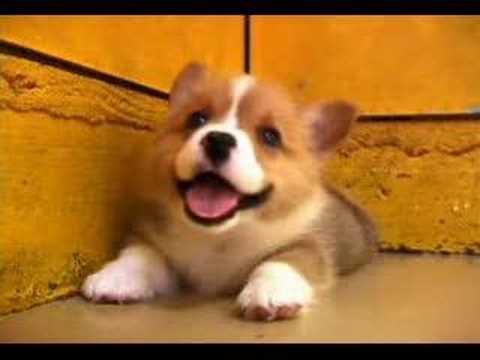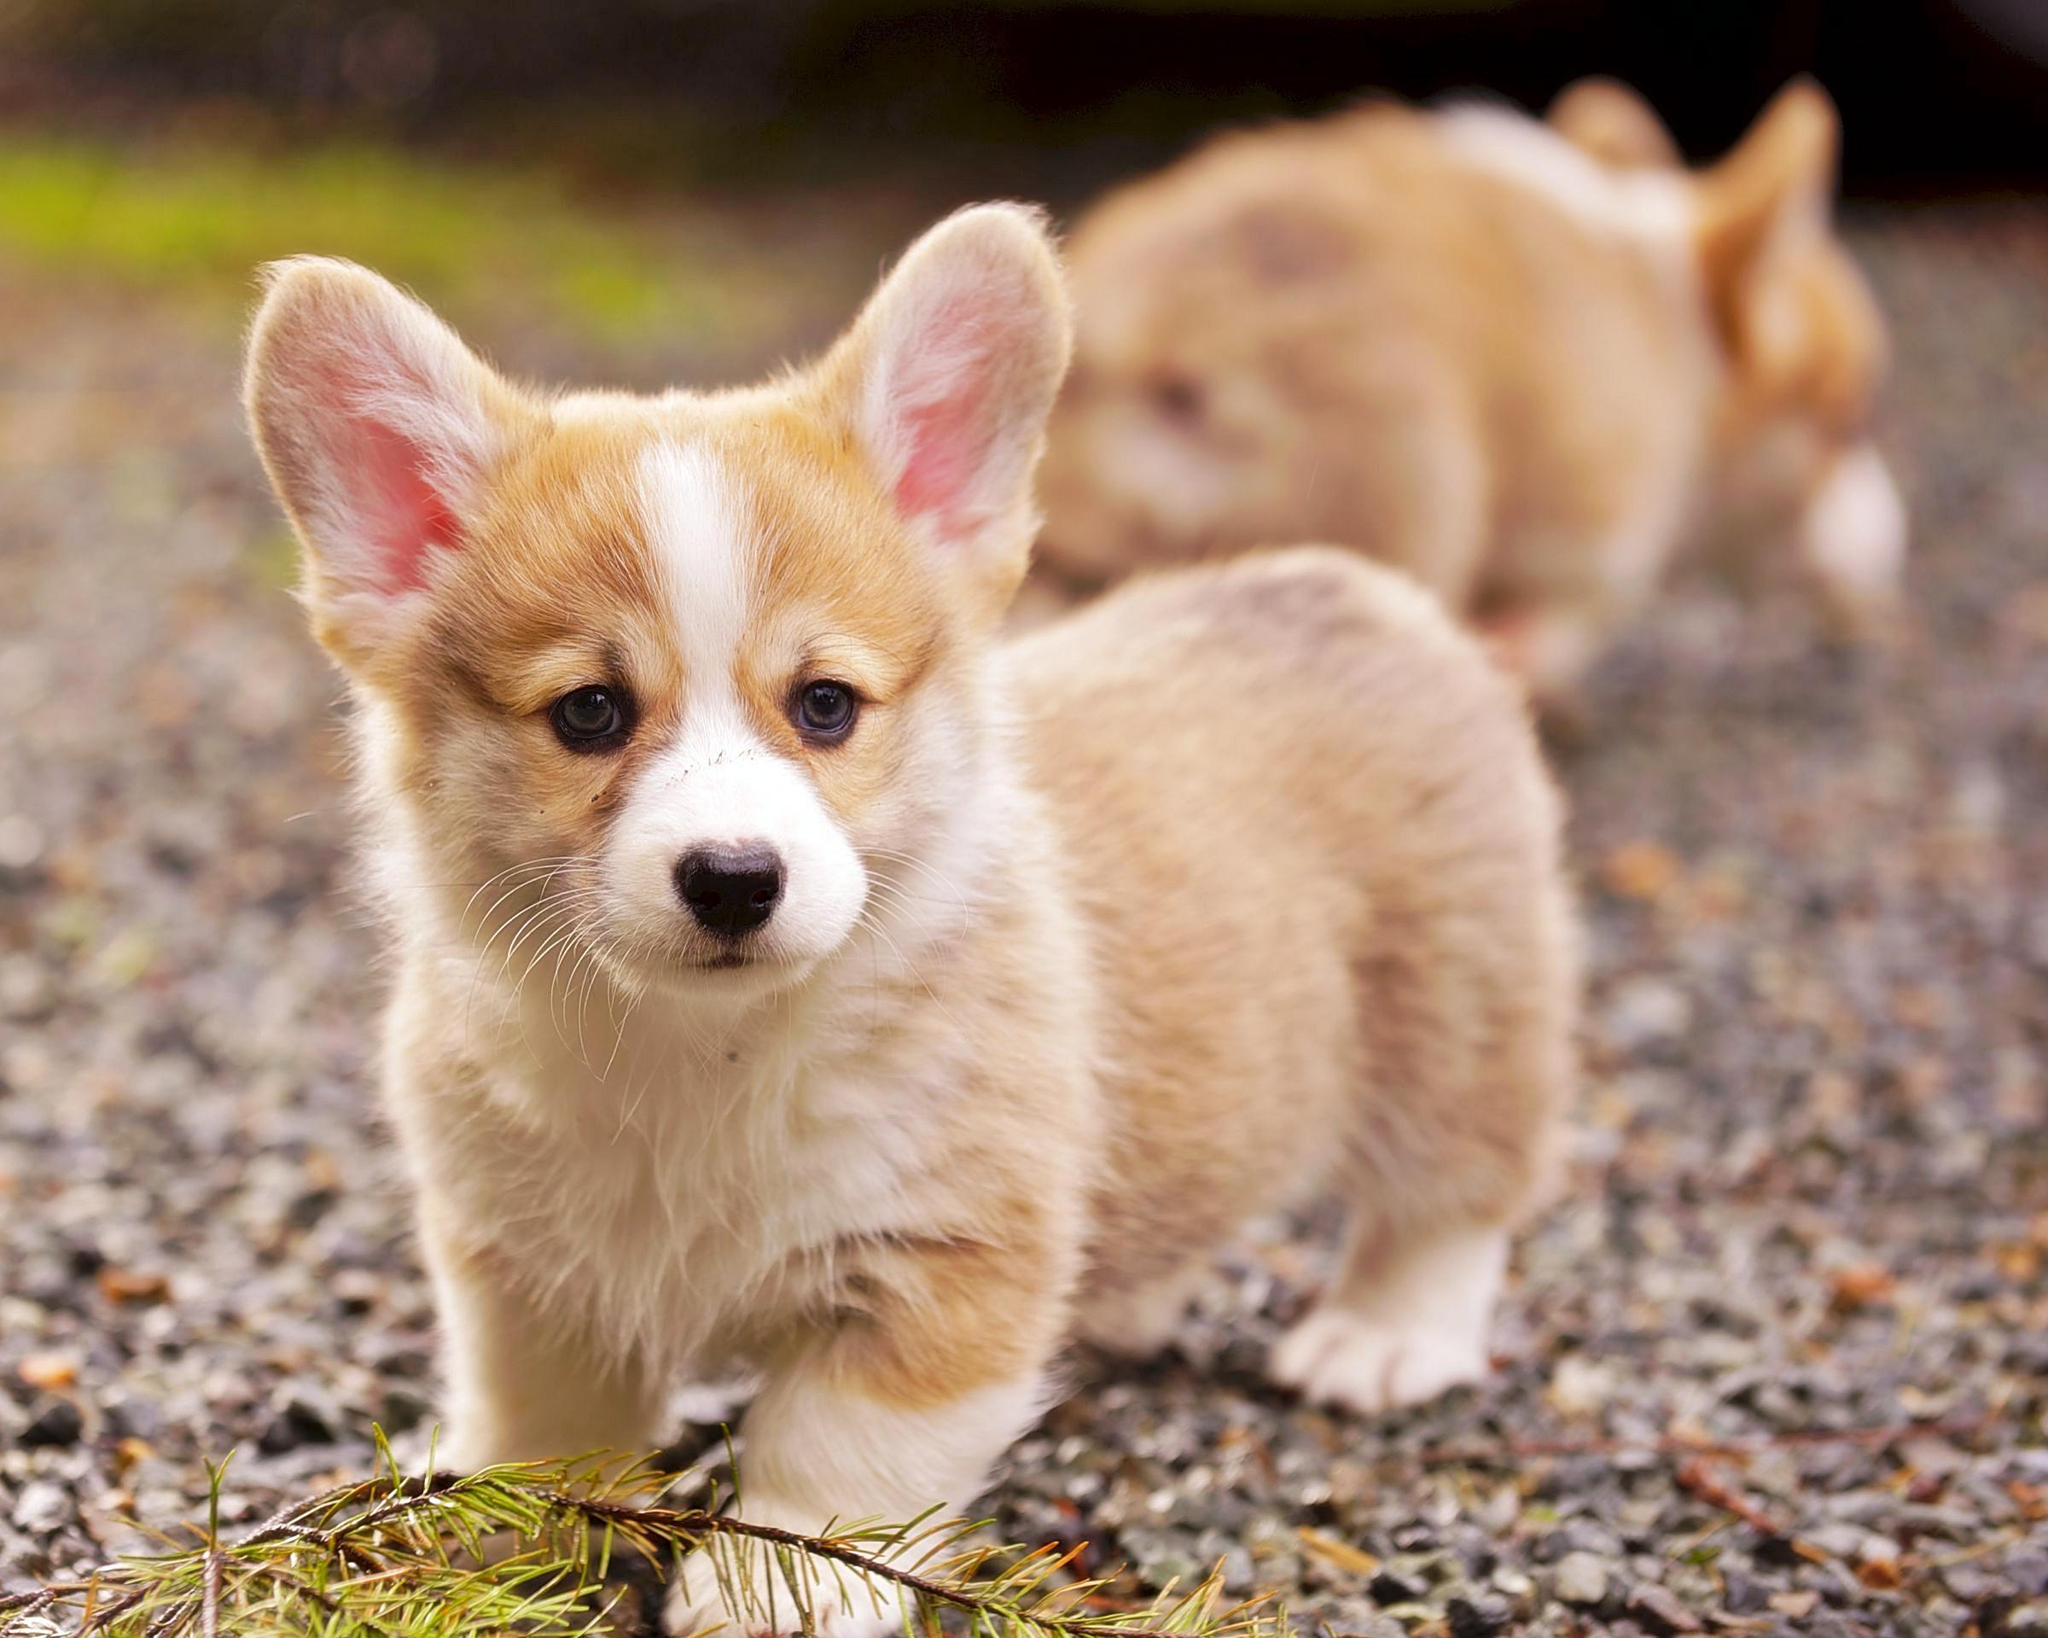The first image is the image on the left, the second image is the image on the right. Examine the images to the left and right. Is the description "Each image shows only one dog, with the dog in the right image orange-and-white, and the dog on the left tri-colored." accurate? Answer yes or no. No. The first image is the image on the left, the second image is the image on the right. For the images displayed, is the sentence "An image contains two dogs." factually correct? Answer yes or no. Yes. 